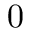Convert formula to latex. <formula><loc_0><loc_0><loc_500><loc_500>0</formula> 